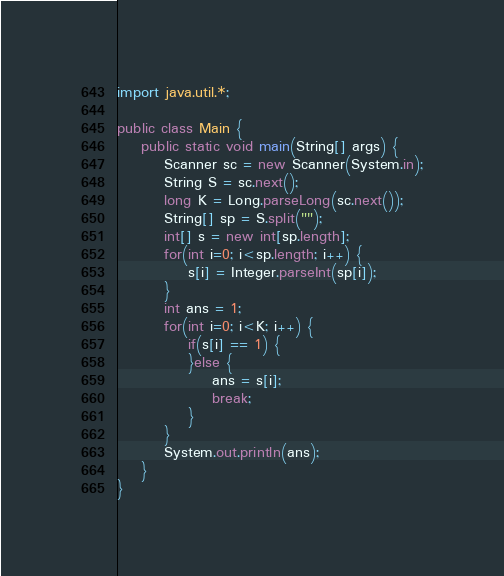Convert code to text. <code><loc_0><loc_0><loc_500><loc_500><_Java_>import java.util.*;
 
public class Main {
    public static void main(String[] args) {
        Scanner sc = new Scanner(System.in);
        String S = sc.next();
        long K = Long.parseLong(sc.next());
        String[] sp = S.split("");
        int[] s = new int[sp.length];
        for(int i=0; i<sp.length; i++) {
            s[i] = Integer.parseInt(sp[i]);
        }
        int ans = 1;
        for(int i=0; i<K; i++) {
            if(s[i] == 1) {
            }else {
                ans = s[i];
                break;
            }
        }
        System.out.println(ans);
    }
}</code> 